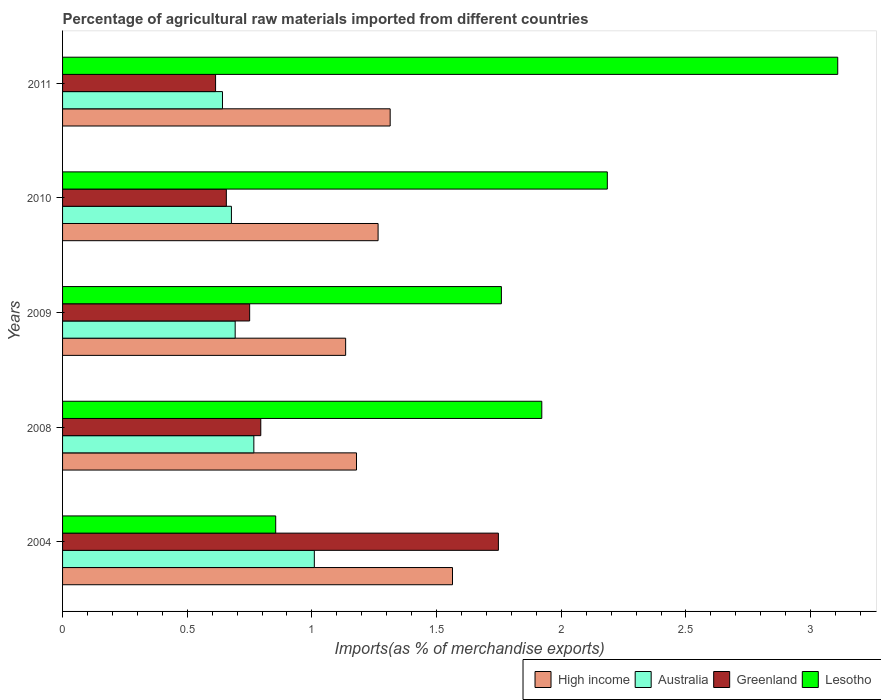How many bars are there on the 2nd tick from the top?
Give a very brief answer. 4. What is the label of the 3rd group of bars from the top?
Provide a succinct answer. 2009. What is the percentage of imports to different countries in Lesotho in 2008?
Your answer should be very brief. 1.92. Across all years, what is the maximum percentage of imports to different countries in High income?
Give a very brief answer. 1.56. Across all years, what is the minimum percentage of imports to different countries in Lesotho?
Give a very brief answer. 0.85. In which year was the percentage of imports to different countries in Lesotho minimum?
Your answer should be very brief. 2004. What is the total percentage of imports to different countries in Lesotho in the graph?
Provide a short and direct response. 9.83. What is the difference between the percentage of imports to different countries in Greenland in 2004 and that in 2009?
Provide a short and direct response. 1. What is the difference between the percentage of imports to different countries in Greenland in 2004 and the percentage of imports to different countries in High income in 2008?
Your answer should be compact. 0.57. What is the average percentage of imports to different countries in Lesotho per year?
Offer a very short reply. 1.97. In the year 2011, what is the difference between the percentage of imports to different countries in Lesotho and percentage of imports to different countries in Greenland?
Provide a succinct answer. 2.5. What is the ratio of the percentage of imports to different countries in Lesotho in 2009 to that in 2011?
Keep it short and to the point. 0.57. What is the difference between the highest and the second highest percentage of imports to different countries in Lesotho?
Keep it short and to the point. 0.92. What is the difference between the highest and the lowest percentage of imports to different countries in Australia?
Offer a very short reply. 0.37. Is the sum of the percentage of imports to different countries in Lesotho in 2008 and 2009 greater than the maximum percentage of imports to different countries in Greenland across all years?
Your response must be concise. Yes. What does the 2nd bar from the top in 2009 represents?
Provide a succinct answer. Greenland. What does the 2nd bar from the bottom in 2004 represents?
Offer a terse response. Australia. Is it the case that in every year, the sum of the percentage of imports to different countries in Australia and percentage of imports to different countries in Lesotho is greater than the percentage of imports to different countries in High income?
Keep it short and to the point. Yes. Does the graph contain any zero values?
Offer a terse response. No. Does the graph contain grids?
Make the answer very short. No. What is the title of the graph?
Provide a succinct answer. Percentage of agricultural raw materials imported from different countries. Does "Egypt, Arab Rep." appear as one of the legend labels in the graph?
Provide a short and direct response. No. What is the label or title of the X-axis?
Provide a succinct answer. Imports(as % of merchandise exports). What is the Imports(as % of merchandise exports) of High income in 2004?
Give a very brief answer. 1.56. What is the Imports(as % of merchandise exports) of Australia in 2004?
Give a very brief answer. 1.01. What is the Imports(as % of merchandise exports) in Greenland in 2004?
Your answer should be compact. 1.75. What is the Imports(as % of merchandise exports) of Lesotho in 2004?
Make the answer very short. 0.85. What is the Imports(as % of merchandise exports) in High income in 2008?
Give a very brief answer. 1.18. What is the Imports(as % of merchandise exports) in Australia in 2008?
Keep it short and to the point. 0.77. What is the Imports(as % of merchandise exports) of Greenland in 2008?
Offer a very short reply. 0.79. What is the Imports(as % of merchandise exports) in Lesotho in 2008?
Give a very brief answer. 1.92. What is the Imports(as % of merchandise exports) of High income in 2009?
Give a very brief answer. 1.14. What is the Imports(as % of merchandise exports) in Australia in 2009?
Make the answer very short. 0.69. What is the Imports(as % of merchandise exports) of Greenland in 2009?
Provide a short and direct response. 0.75. What is the Imports(as % of merchandise exports) in Lesotho in 2009?
Your response must be concise. 1.76. What is the Imports(as % of merchandise exports) of High income in 2010?
Your answer should be compact. 1.27. What is the Imports(as % of merchandise exports) of Australia in 2010?
Keep it short and to the point. 0.68. What is the Imports(as % of merchandise exports) of Greenland in 2010?
Keep it short and to the point. 0.66. What is the Imports(as % of merchandise exports) of Lesotho in 2010?
Provide a succinct answer. 2.18. What is the Imports(as % of merchandise exports) in High income in 2011?
Offer a terse response. 1.31. What is the Imports(as % of merchandise exports) in Australia in 2011?
Your answer should be very brief. 0.64. What is the Imports(as % of merchandise exports) in Greenland in 2011?
Offer a very short reply. 0.61. What is the Imports(as % of merchandise exports) in Lesotho in 2011?
Offer a very short reply. 3.11. Across all years, what is the maximum Imports(as % of merchandise exports) in High income?
Provide a short and direct response. 1.56. Across all years, what is the maximum Imports(as % of merchandise exports) of Australia?
Keep it short and to the point. 1.01. Across all years, what is the maximum Imports(as % of merchandise exports) of Greenland?
Your answer should be compact. 1.75. Across all years, what is the maximum Imports(as % of merchandise exports) in Lesotho?
Give a very brief answer. 3.11. Across all years, what is the minimum Imports(as % of merchandise exports) in High income?
Your answer should be compact. 1.14. Across all years, what is the minimum Imports(as % of merchandise exports) of Australia?
Make the answer very short. 0.64. Across all years, what is the minimum Imports(as % of merchandise exports) in Greenland?
Your answer should be compact. 0.61. Across all years, what is the minimum Imports(as % of merchandise exports) of Lesotho?
Offer a terse response. 0.85. What is the total Imports(as % of merchandise exports) of High income in the graph?
Provide a short and direct response. 6.46. What is the total Imports(as % of merchandise exports) in Australia in the graph?
Give a very brief answer. 3.79. What is the total Imports(as % of merchandise exports) in Greenland in the graph?
Make the answer very short. 4.56. What is the total Imports(as % of merchandise exports) in Lesotho in the graph?
Ensure brevity in your answer.  9.83. What is the difference between the Imports(as % of merchandise exports) in High income in 2004 and that in 2008?
Offer a terse response. 0.39. What is the difference between the Imports(as % of merchandise exports) in Australia in 2004 and that in 2008?
Offer a terse response. 0.24. What is the difference between the Imports(as % of merchandise exports) in Greenland in 2004 and that in 2008?
Your answer should be compact. 0.95. What is the difference between the Imports(as % of merchandise exports) of Lesotho in 2004 and that in 2008?
Offer a terse response. -1.07. What is the difference between the Imports(as % of merchandise exports) in High income in 2004 and that in 2009?
Provide a succinct answer. 0.43. What is the difference between the Imports(as % of merchandise exports) in Australia in 2004 and that in 2009?
Provide a succinct answer. 0.32. What is the difference between the Imports(as % of merchandise exports) of Greenland in 2004 and that in 2009?
Offer a very short reply. 1. What is the difference between the Imports(as % of merchandise exports) in Lesotho in 2004 and that in 2009?
Offer a very short reply. -0.91. What is the difference between the Imports(as % of merchandise exports) of High income in 2004 and that in 2010?
Provide a succinct answer. 0.3. What is the difference between the Imports(as % of merchandise exports) of Australia in 2004 and that in 2010?
Ensure brevity in your answer.  0.33. What is the difference between the Imports(as % of merchandise exports) in Greenland in 2004 and that in 2010?
Your response must be concise. 1.09. What is the difference between the Imports(as % of merchandise exports) in Lesotho in 2004 and that in 2010?
Offer a very short reply. -1.33. What is the difference between the Imports(as % of merchandise exports) of Australia in 2004 and that in 2011?
Offer a very short reply. 0.37. What is the difference between the Imports(as % of merchandise exports) in Greenland in 2004 and that in 2011?
Your answer should be very brief. 1.13. What is the difference between the Imports(as % of merchandise exports) in Lesotho in 2004 and that in 2011?
Make the answer very short. -2.25. What is the difference between the Imports(as % of merchandise exports) of High income in 2008 and that in 2009?
Offer a very short reply. 0.04. What is the difference between the Imports(as % of merchandise exports) of Australia in 2008 and that in 2009?
Offer a terse response. 0.07. What is the difference between the Imports(as % of merchandise exports) in Greenland in 2008 and that in 2009?
Offer a terse response. 0.04. What is the difference between the Imports(as % of merchandise exports) in Lesotho in 2008 and that in 2009?
Your answer should be very brief. 0.16. What is the difference between the Imports(as % of merchandise exports) in High income in 2008 and that in 2010?
Keep it short and to the point. -0.09. What is the difference between the Imports(as % of merchandise exports) in Australia in 2008 and that in 2010?
Keep it short and to the point. 0.09. What is the difference between the Imports(as % of merchandise exports) in Greenland in 2008 and that in 2010?
Provide a succinct answer. 0.14. What is the difference between the Imports(as % of merchandise exports) of Lesotho in 2008 and that in 2010?
Your response must be concise. -0.26. What is the difference between the Imports(as % of merchandise exports) in High income in 2008 and that in 2011?
Your answer should be compact. -0.14. What is the difference between the Imports(as % of merchandise exports) of Australia in 2008 and that in 2011?
Provide a succinct answer. 0.13. What is the difference between the Imports(as % of merchandise exports) of Greenland in 2008 and that in 2011?
Give a very brief answer. 0.18. What is the difference between the Imports(as % of merchandise exports) in Lesotho in 2008 and that in 2011?
Your answer should be very brief. -1.19. What is the difference between the Imports(as % of merchandise exports) in High income in 2009 and that in 2010?
Provide a short and direct response. -0.13. What is the difference between the Imports(as % of merchandise exports) of Australia in 2009 and that in 2010?
Keep it short and to the point. 0.02. What is the difference between the Imports(as % of merchandise exports) in Greenland in 2009 and that in 2010?
Your response must be concise. 0.09. What is the difference between the Imports(as % of merchandise exports) of Lesotho in 2009 and that in 2010?
Your answer should be very brief. -0.42. What is the difference between the Imports(as % of merchandise exports) in High income in 2009 and that in 2011?
Make the answer very short. -0.18. What is the difference between the Imports(as % of merchandise exports) of Australia in 2009 and that in 2011?
Provide a short and direct response. 0.05. What is the difference between the Imports(as % of merchandise exports) in Greenland in 2009 and that in 2011?
Give a very brief answer. 0.14. What is the difference between the Imports(as % of merchandise exports) in Lesotho in 2009 and that in 2011?
Provide a short and direct response. -1.35. What is the difference between the Imports(as % of merchandise exports) in High income in 2010 and that in 2011?
Keep it short and to the point. -0.05. What is the difference between the Imports(as % of merchandise exports) in Australia in 2010 and that in 2011?
Your response must be concise. 0.04. What is the difference between the Imports(as % of merchandise exports) in Greenland in 2010 and that in 2011?
Provide a succinct answer. 0.04. What is the difference between the Imports(as % of merchandise exports) of Lesotho in 2010 and that in 2011?
Offer a terse response. -0.92. What is the difference between the Imports(as % of merchandise exports) of High income in 2004 and the Imports(as % of merchandise exports) of Australia in 2008?
Provide a succinct answer. 0.8. What is the difference between the Imports(as % of merchandise exports) of High income in 2004 and the Imports(as % of merchandise exports) of Greenland in 2008?
Ensure brevity in your answer.  0.77. What is the difference between the Imports(as % of merchandise exports) of High income in 2004 and the Imports(as % of merchandise exports) of Lesotho in 2008?
Keep it short and to the point. -0.36. What is the difference between the Imports(as % of merchandise exports) in Australia in 2004 and the Imports(as % of merchandise exports) in Greenland in 2008?
Offer a terse response. 0.21. What is the difference between the Imports(as % of merchandise exports) of Australia in 2004 and the Imports(as % of merchandise exports) of Lesotho in 2008?
Provide a short and direct response. -0.91. What is the difference between the Imports(as % of merchandise exports) of Greenland in 2004 and the Imports(as % of merchandise exports) of Lesotho in 2008?
Make the answer very short. -0.17. What is the difference between the Imports(as % of merchandise exports) of High income in 2004 and the Imports(as % of merchandise exports) of Australia in 2009?
Provide a succinct answer. 0.87. What is the difference between the Imports(as % of merchandise exports) of High income in 2004 and the Imports(as % of merchandise exports) of Greenland in 2009?
Ensure brevity in your answer.  0.81. What is the difference between the Imports(as % of merchandise exports) of High income in 2004 and the Imports(as % of merchandise exports) of Lesotho in 2009?
Keep it short and to the point. -0.2. What is the difference between the Imports(as % of merchandise exports) in Australia in 2004 and the Imports(as % of merchandise exports) in Greenland in 2009?
Provide a succinct answer. 0.26. What is the difference between the Imports(as % of merchandise exports) in Australia in 2004 and the Imports(as % of merchandise exports) in Lesotho in 2009?
Your answer should be very brief. -0.75. What is the difference between the Imports(as % of merchandise exports) of Greenland in 2004 and the Imports(as % of merchandise exports) of Lesotho in 2009?
Ensure brevity in your answer.  -0.01. What is the difference between the Imports(as % of merchandise exports) of High income in 2004 and the Imports(as % of merchandise exports) of Australia in 2010?
Make the answer very short. 0.89. What is the difference between the Imports(as % of merchandise exports) in High income in 2004 and the Imports(as % of merchandise exports) in Greenland in 2010?
Your response must be concise. 0.91. What is the difference between the Imports(as % of merchandise exports) in High income in 2004 and the Imports(as % of merchandise exports) in Lesotho in 2010?
Make the answer very short. -0.62. What is the difference between the Imports(as % of merchandise exports) in Australia in 2004 and the Imports(as % of merchandise exports) in Greenland in 2010?
Offer a very short reply. 0.35. What is the difference between the Imports(as % of merchandise exports) of Australia in 2004 and the Imports(as % of merchandise exports) of Lesotho in 2010?
Give a very brief answer. -1.18. What is the difference between the Imports(as % of merchandise exports) in Greenland in 2004 and the Imports(as % of merchandise exports) in Lesotho in 2010?
Provide a succinct answer. -0.44. What is the difference between the Imports(as % of merchandise exports) of High income in 2004 and the Imports(as % of merchandise exports) of Australia in 2011?
Your response must be concise. 0.92. What is the difference between the Imports(as % of merchandise exports) of High income in 2004 and the Imports(as % of merchandise exports) of Greenland in 2011?
Offer a very short reply. 0.95. What is the difference between the Imports(as % of merchandise exports) of High income in 2004 and the Imports(as % of merchandise exports) of Lesotho in 2011?
Give a very brief answer. -1.54. What is the difference between the Imports(as % of merchandise exports) of Australia in 2004 and the Imports(as % of merchandise exports) of Greenland in 2011?
Provide a short and direct response. 0.4. What is the difference between the Imports(as % of merchandise exports) in Australia in 2004 and the Imports(as % of merchandise exports) in Lesotho in 2011?
Make the answer very short. -2.1. What is the difference between the Imports(as % of merchandise exports) of Greenland in 2004 and the Imports(as % of merchandise exports) of Lesotho in 2011?
Provide a short and direct response. -1.36. What is the difference between the Imports(as % of merchandise exports) in High income in 2008 and the Imports(as % of merchandise exports) in Australia in 2009?
Offer a terse response. 0.49. What is the difference between the Imports(as % of merchandise exports) of High income in 2008 and the Imports(as % of merchandise exports) of Greenland in 2009?
Provide a succinct answer. 0.43. What is the difference between the Imports(as % of merchandise exports) in High income in 2008 and the Imports(as % of merchandise exports) in Lesotho in 2009?
Your response must be concise. -0.58. What is the difference between the Imports(as % of merchandise exports) of Australia in 2008 and the Imports(as % of merchandise exports) of Greenland in 2009?
Offer a very short reply. 0.02. What is the difference between the Imports(as % of merchandise exports) in Australia in 2008 and the Imports(as % of merchandise exports) in Lesotho in 2009?
Keep it short and to the point. -0.99. What is the difference between the Imports(as % of merchandise exports) in Greenland in 2008 and the Imports(as % of merchandise exports) in Lesotho in 2009?
Your answer should be very brief. -0.96. What is the difference between the Imports(as % of merchandise exports) of High income in 2008 and the Imports(as % of merchandise exports) of Australia in 2010?
Your answer should be very brief. 0.5. What is the difference between the Imports(as % of merchandise exports) in High income in 2008 and the Imports(as % of merchandise exports) in Greenland in 2010?
Keep it short and to the point. 0.52. What is the difference between the Imports(as % of merchandise exports) of High income in 2008 and the Imports(as % of merchandise exports) of Lesotho in 2010?
Provide a short and direct response. -1.01. What is the difference between the Imports(as % of merchandise exports) of Australia in 2008 and the Imports(as % of merchandise exports) of Greenland in 2010?
Your answer should be compact. 0.11. What is the difference between the Imports(as % of merchandise exports) in Australia in 2008 and the Imports(as % of merchandise exports) in Lesotho in 2010?
Keep it short and to the point. -1.42. What is the difference between the Imports(as % of merchandise exports) of Greenland in 2008 and the Imports(as % of merchandise exports) of Lesotho in 2010?
Give a very brief answer. -1.39. What is the difference between the Imports(as % of merchandise exports) in High income in 2008 and the Imports(as % of merchandise exports) in Australia in 2011?
Ensure brevity in your answer.  0.54. What is the difference between the Imports(as % of merchandise exports) in High income in 2008 and the Imports(as % of merchandise exports) in Greenland in 2011?
Give a very brief answer. 0.57. What is the difference between the Imports(as % of merchandise exports) in High income in 2008 and the Imports(as % of merchandise exports) in Lesotho in 2011?
Provide a succinct answer. -1.93. What is the difference between the Imports(as % of merchandise exports) of Australia in 2008 and the Imports(as % of merchandise exports) of Greenland in 2011?
Your response must be concise. 0.15. What is the difference between the Imports(as % of merchandise exports) of Australia in 2008 and the Imports(as % of merchandise exports) of Lesotho in 2011?
Your answer should be very brief. -2.34. What is the difference between the Imports(as % of merchandise exports) in Greenland in 2008 and the Imports(as % of merchandise exports) in Lesotho in 2011?
Make the answer very short. -2.31. What is the difference between the Imports(as % of merchandise exports) of High income in 2009 and the Imports(as % of merchandise exports) of Australia in 2010?
Offer a very short reply. 0.46. What is the difference between the Imports(as % of merchandise exports) in High income in 2009 and the Imports(as % of merchandise exports) in Greenland in 2010?
Offer a very short reply. 0.48. What is the difference between the Imports(as % of merchandise exports) in High income in 2009 and the Imports(as % of merchandise exports) in Lesotho in 2010?
Give a very brief answer. -1.05. What is the difference between the Imports(as % of merchandise exports) of Australia in 2009 and the Imports(as % of merchandise exports) of Greenland in 2010?
Provide a short and direct response. 0.04. What is the difference between the Imports(as % of merchandise exports) in Australia in 2009 and the Imports(as % of merchandise exports) in Lesotho in 2010?
Offer a very short reply. -1.49. What is the difference between the Imports(as % of merchandise exports) in Greenland in 2009 and the Imports(as % of merchandise exports) in Lesotho in 2010?
Keep it short and to the point. -1.43. What is the difference between the Imports(as % of merchandise exports) in High income in 2009 and the Imports(as % of merchandise exports) in Australia in 2011?
Offer a terse response. 0.49. What is the difference between the Imports(as % of merchandise exports) in High income in 2009 and the Imports(as % of merchandise exports) in Greenland in 2011?
Keep it short and to the point. 0.52. What is the difference between the Imports(as % of merchandise exports) in High income in 2009 and the Imports(as % of merchandise exports) in Lesotho in 2011?
Provide a succinct answer. -1.97. What is the difference between the Imports(as % of merchandise exports) of Australia in 2009 and the Imports(as % of merchandise exports) of Greenland in 2011?
Keep it short and to the point. 0.08. What is the difference between the Imports(as % of merchandise exports) in Australia in 2009 and the Imports(as % of merchandise exports) in Lesotho in 2011?
Make the answer very short. -2.42. What is the difference between the Imports(as % of merchandise exports) of Greenland in 2009 and the Imports(as % of merchandise exports) of Lesotho in 2011?
Your answer should be very brief. -2.36. What is the difference between the Imports(as % of merchandise exports) in High income in 2010 and the Imports(as % of merchandise exports) in Australia in 2011?
Your answer should be compact. 0.62. What is the difference between the Imports(as % of merchandise exports) in High income in 2010 and the Imports(as % of merchandise exports) in Greenland in 2011?
Your response must be concise. 0.65. What is the difference between the Imports(as % of merchandise exports) of High income in 2010 and the Imports(as % of merchandise exports) of Lesotho in 2011?
Make the answer very short. -1.84. What is the difference between the Imports(as % of merchandise exports) in Australia in 2010 and the Imports(as % of merchandise exports) in Greenland in 2011?
Keep it short and to the point. 0.06. What is the difference between the Imports(as % of merchandise exports) of Australia in 2010 and the Imports(as % of merchandise exports) of Lesotho in 2011?
Make the answer very short. -2.43. What is the difference between the Imports(as % of merchandise exports) in Greenland in 2010 and the Imports(as % of merchandise exports) in Lesotho in 2011?
Offer a terse response. -2.45. What is the average Imports(as % of merchandise exports) in High income per year?
Offer a terse response. 1.29. What is the average Imports(as % of merchandise exports) of Australia per year?
Make the answer very short. 0.76. What is the average Imports(as % of merchandise exports) in Greenland per year?
Your response must be concise. 0.91. What is the average Imports(as % of merchandise exports) in Lesotho per year?
Give a very brief answer. 1.97. In the year 2004, what is the difference between the Imports(as % of merchandise exports) in High income and Imports(as % of merchandise exports) in Australia?
Offer a very short reply. 0.55. In the year 2004, what is the difference between the Imports(as % of merchandise exports) in High income and Imports(as % of merchandise exports) in Greenland?
Your response must be concise. -0.18. In the year 2004, what is the difference between the Imports(as % of merchandise exports) in High income and Imports(as % of merchandise exports) in Lesotho?
Provide a succinct answer. 0.71. In the year 2004, what is the difference between the Imports(as % of merchandise exports) in Australia and Imports(as % of merchandise exports) in Greenland?
Give a very brief answer. -0.74. In the year 2004, what is the difference between the Imports(as % of merchandise exports) in Australia and Imports(as % of merchandise exports) in Lesotho?
Provide a short and direct response. 0.15. In the year 2004, what is the difference between the Imports(as % of merchandise exports) of Greenland and Imports(as % of merchandise exports) of Lesotho?
Ensure brevity in your answer.  0.89. In the year 2008, what is the difference between the Imports(as % of merchandise exports) of High income and Imports(as % of merchandise exports) of Australia?
Keep it short and to the point. 0.41. In the year 2008, what is the difference between the Imports(as % of merchandise exports) in High income and Imports(as % of merchandise exports) in Greenland?
Your response must be concise. 0.38. In the year 2008, what is the difference between the Imports(as % of merchandise exports) in High income and Imports(as % of merchandise exports) in Lesotho?
Provide a succinct answer. -0.74. In the year 2008, what is the difference between the Imports(as % of merchandise exports) of Australia and Imports(as % of merchandise exports) of Greenland?
Ensure brevity in your answer.  -0.03. In the year 2008, what is the difference between the Imports(as % of merchandise exports) of Australia and Imports(as % of merchandise exports) of Lesotho?
Make the answer very short. -1.15. In the year 2008, what is the difference between the Imports(as % of merchandise exports) in Greenland and Imports(as % of merchandise exports) in Lesotho?
Provide a short and direct response. -1.13. In the year 2009, what is the difference between the Imports(as % of merchandise exports) in High income and Imports(as % of merchandise exports) in Australia?
Keep it short and to the point. 0.44. In the year 2009, what is the difference between the Imports(as % of merchandise exports) of High income and Imports(as % of merchandise exports) of Greenland?
Your answer should be very brief. 0.38. In the year 2009, what is the difference between the Imports(as % of merchandise exports) in High income and Imports(as % of merchandise exports) in Lesotho?
Offer a terse response. -0.62. In the year 2009, what is the difference between the Imports(as % of merchandise exports) of Australia and Imports(as % of merchandise exports) of Greenland?
Offer a very short reply. -0.06. In the year 2009, what is the difference between the Imports(as % of merchandise exports) of Australia and Imports(as % of merchandise exports) of Lesotho?
Give a very brief answer. -1.07. In the year 2009, what is the difference between the Imports(as % of merchandise exports) of Greenland and Imports(as % of merchandise exports) of Lesotho?
Keep it short and to the point. -1.01. In the year 2010, what is the difference between the Imports(as % of merchandise exports) of High income and Imports(as % of merchandise exports) of Australia?
Your response must be concise. 0.59. In the year 2010, what is the difference between the Imports(as % of merchandise exports) in High income and Imports(as % of merchandise exports) in Greenland?
Your answer should be compact. 0.61. In the year 2010, what is the difference between the Imports(as % of merchandise exports) of High income and Imports(as % of merchandise exports) of Lesotho?
Keep it short and to the point. -0.92. In the year 2010, what is the difference between the Imports(as % of merchandise exports) in Australia and Imports(as % of merchandise exports) in Greenland?
Ensure brevity in your answer.  0.02. In the year 2010, what is the difference between the Imports(as % of merchandise exports) in Australia and Imports(as % of merchandise exports) in Lesotho?
Make the answer very short. -1.51. In the year 2010, what is the difference between the Imports(as % of merchandise exports) of Greenland and Imports(as % of merchandise exports) of Lesotho?
Offer a very short reply. -1.53. In the year 2011, what is the difference between the Imports(as % of merchandise exports) in High income and Imports(as % of merchandise exports) in Australia?
Ensure brevity in your answer.  0.67. In the year 2011, what is the difference between the Imports(as % of merchandise exports) of High income and Imports(as % of merchandise exports) of Greenland?
Keep it short and to the point. 0.7. In the year 2011, what is the difference between the Imports(as % of merchandise exports) of High income and Imports(as % of merchandise exports) of Lesotho?
Provide a short and direct response. -1.79. In the year 2011, what is the difference between the Imports(as % of merchandise exports) in Australia and Imports(as % of merchandise exports) in Greenland?
Your answer should be very brief. 0.03. In the year 2011, what is the difference between the Imports(as % of merchandise exports) in Australia and Imports(as % of merchandise exports) in Lesotho?
Your response must be concise. -2.47. In the year 2011, what is the difference between the Imports(as % of merchandise exports) of Greenland and Imports(as % of merchandise exports) of Lesotho?
Offer a terse response. -2.5. What is the ratio of the Imports(as % of merchandise exports) in High income in 2004 to that in 2008?
Ensure brevity in your answer.  1.33. What is the ratio of the Imports(as % of merchandise exports) in Australia in 2004 to that in 2008?
Your answer should be very brief. 1.32. What is the ratio of the Imports(as % of merchandise exports) in Greenland in 2004 to that in 2008?
Give a very brief answer. 2.2. What is the ratio of the Imports(as % of merchandise exports) in Lesotho in 2004 to that in 2008?
Ensure brevity in your answer.  0.44. What is the ratio of the Imports(as % of merchandise exports) in High income in 2004 to that in 2009?
Your answer should be very brief. 1.38. What is the ratio of the Imports(as % of merchandise exports) in Australia in 2004 to that in 2009?
Give a very brief answer. 1.46. What is the ratio of the Imports(as % of merchandise exports) in Greenland in 2004 to that in 2009?
Offer a terse response. 2.33. What is the ratio of the Imports(as % of merchandise exports) of Lesotho in 2004 to that in 2009?
Your answer should be compact. 0.49. What is the ratio of the Imports(as % of merchandise exports) in High income in 2004 to that in 2010?
Ensure brevity in your answer.  1.24. What is the ratio of the Imports(as % of merchandise exports) in Australia in 2004 to that in 2010?
Ensure brevity in your answer.  1.49. What is the ratio of the Imports(as % of merchandise exports) of Greenland in 2004 to that in 2010?
Provide a succinct answer. 2.66. What is the ratio of the Imports(as % of merchandise exports) in Lesotho in 2004 to that in 2010?
Offer a very short reply. 0.39. What is the ratio of the Imports(as % of merchandise exports) of High income in 2004 to that in 2011?
Provide a succinct answer. 1.19. What is the ratio of the Imports(as % of merchandise exports) in Australia in 2004 to that in 2011?
Your answer should be very brief. 1.57. What is the ratio of the Imports(as % of merchandise exports) in Greenland in 2004 to that in 2011?
Your answer should be very brief. 2.85. What is the ratio of the Imports(as % of merchandise exports) in Lesotho in 2004 to that in 2011?
Keep it short and to the point. 0.28. What is the ratio of the Imports(as % of merchandise exports) of High income in 2008 to that in 2009?
Provide a succinct answer. 1.04. What is the ratio of the Imports(as % of merchandise exports) in Australia in 2008 to that in 2009?
Ensure brevity in your answer.  1.11. What is the ratio of the Imports(as % of merchandise exports) in Greenland in 2008 to that in 2009?
Your answer should be very brief. 1.06. What is the ratio of the Imports(as % of merchandise exports) of Lesotho in 2008 to that in 2009?
Ensure brevity in your answer.  1.09. What is the ratio of the Imports(as % of merchandise exports) of High income in 2008 to that in 2010?
Your answer should be very brief. 0.93. What is the ratio of the Imports(as % of merchandise exports) in Australia in 2008 to that in 2010?
Your response must be concise. 1.13. What is the ratio of the Imports(as % of merchandise exports) in Greenland in 2008 to that in 2010?
Keep it short and to the point. 1.21. What is the ratio of the Imports(as % of merchandise exports) of Lesotho in 2008 to that in 2010?
Provide a short and direct response. 0.88. What is the ratio of the Imports(as % of merchandise exports) in High income in 2008 to that in 2011?
Provide a succinct answer. 0.9. What is the ratio of the Imports(as % of merchandise exports) of Australia in 2008 to that in 2011?
Provide a succinct answer. 1.2. What is the ratio of the Imports(as % of merchandise exports) of Greenland in 2008 to that in 2011?
Provide a succinct answer. 1.3. What is the ratio of the Imports(as % of merchandise exports) of Lesotho in 2008 to that in 2011?
Offer a very short reply. 0.62. What is the ratio of the Imports(as % of merchandise exports) of High income in 2009 to that in 2010?
Ensure brevity in your answer.  0.9. What is the ratio of the Imports(as % of merchandise exports) of Australia in 2009 to that in 2010?
Make the answer very short. 1.02. What is the ratio of the Imports(as % of merchandise exports) in Greenland in 2009 to that in 2010?
Offer a terse response. 1.14. What is the ratio of the Imports(as % of merchandise exports) in Lesotho in 2009 to that in 2010?
Give a very brief answer. 0.81. What is the ratio of the Imports(as % of merchandise exports) of High income in 2009 to that in 2011?
Offer a very short reply. 0.86. What is the ratio of the Imports(as % of merchandise exports) in Australia in 2009 to that in 2011?
Offer a terse response. 1.08. What is the ratio of the Imports(as % of merchandise exports) of Greenland in 2009 to that in 2011?
Your answer should be compact. 1.22. What is the ratio of the Imports(as % of merchandise exports) of Lesotho in 2009 to that in 2011?
Make the answer very short. 0.57. What is the ratio of the Imports(as % of merchandise exports) in High income in 2010 to that in 2011?
Your answer should be compact. 0.96. What is the ratio of the Imports(as % of merchandise exports) in Australia in 2010 to that in 2011?
Give a very brief answer. 1.06. What is the ratio of the Imports(as % of merchandise exports) of Greenland in 2010 to that in 2011?
Keep it short and to the point. 1.07. What is the ratio of the Imports(as % of merchandise exports) in Lesotho in 2010 to that in 2011?
Offer a terse response. 0.7. What is the difference between the highest and the second highest Imports(as % of merchandise exports) in Australia?
Keep it short and to the point. 0.24. What is the difference between the highest and the second highest Imports(as % of merchandise exports) of Greenland?
Your answer should be compact. 0.95. What is the difference between the highest and the second highest Imports(as % of merchandise exports) of Lesotho?
Give a very brief answer. 0.92. What is the difference between the highest and the lowest Imports(as % of merchandise exports) of High income?
Give a very brief answer. 0.43. What is the difference between the highest and the lowest Imports(as % of merchandise exports) of Australia?
Your answer should be compact. 0.37. What is the difference between the highest and the lowest Imports(as % of merchandise exports) in Greenland?
Offer a very short reply. 1.13. What is the difference between the highest and the lowest Imports(as % of merchandise exports) of Lesotho?
Give a very brief answer. 2.25. 